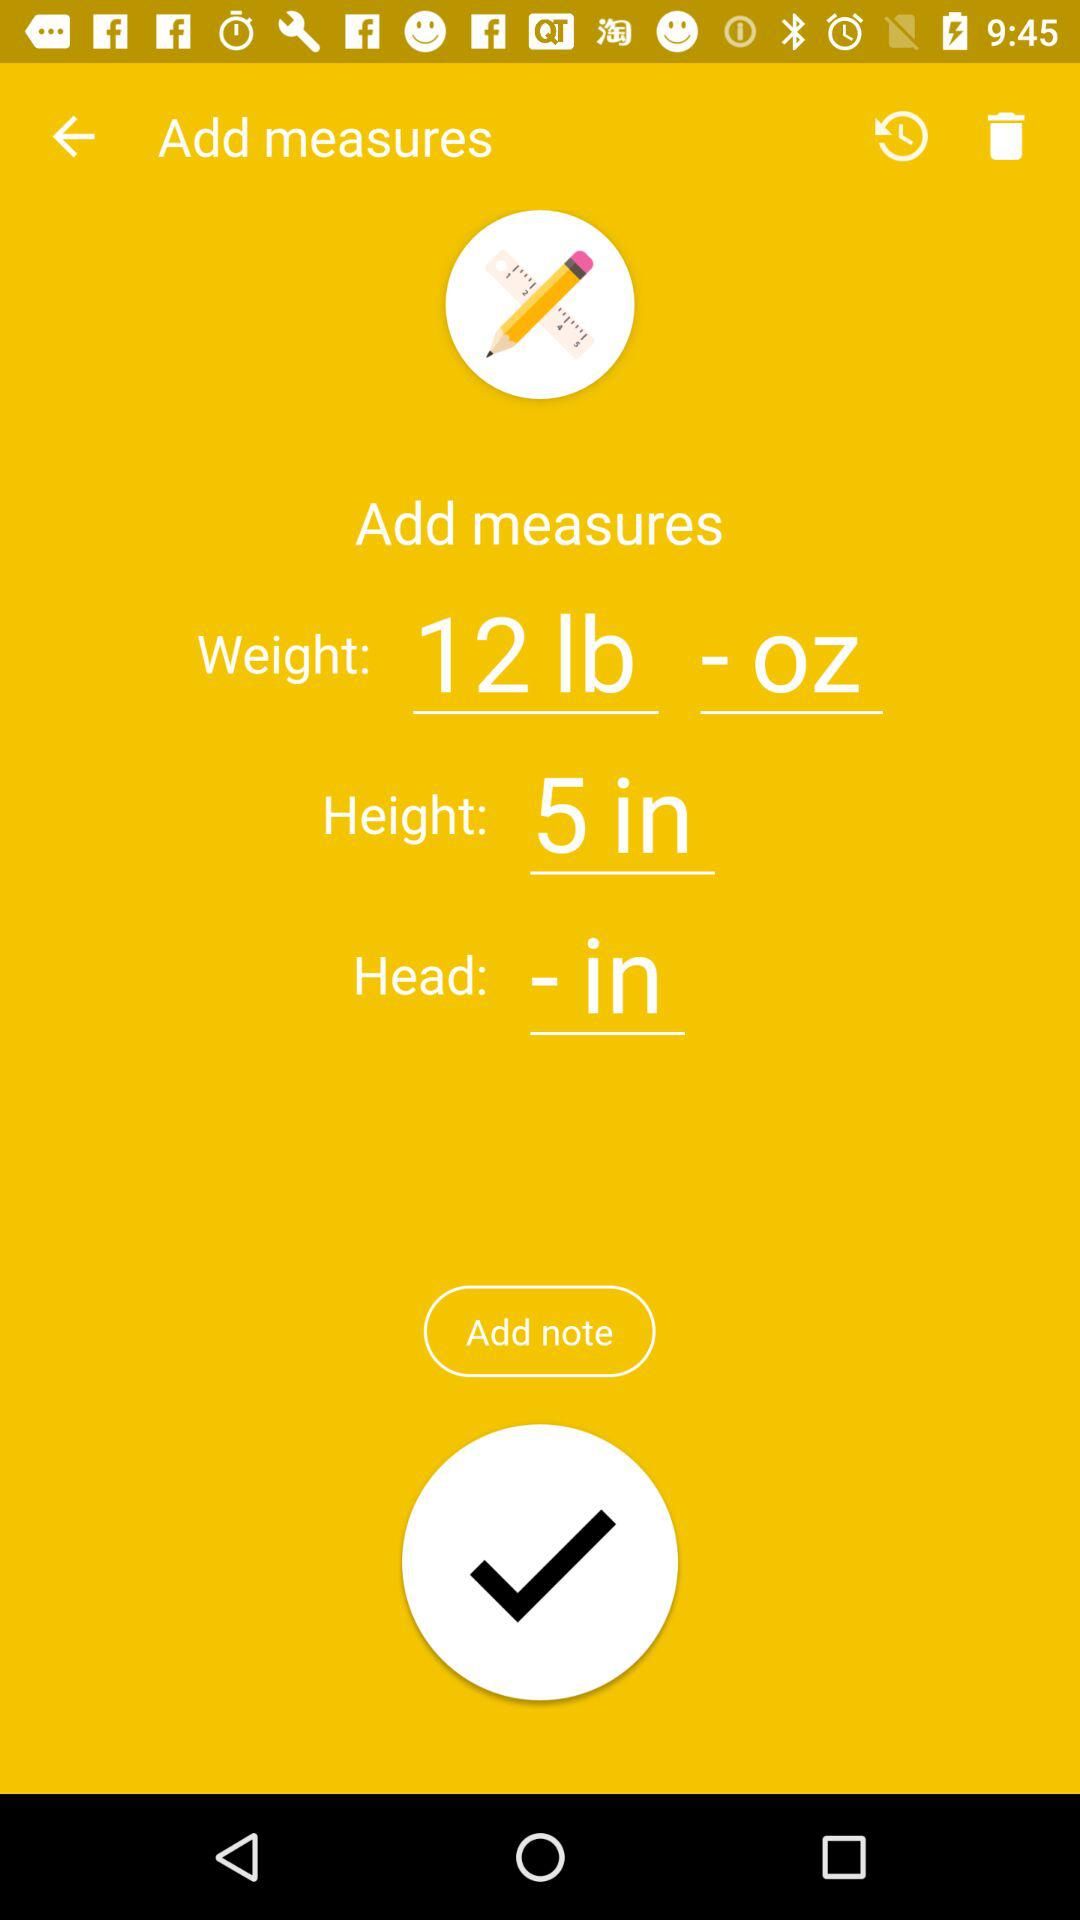How many inches are there in the height measurement?
Answer the question using a single word or phrase. 5 